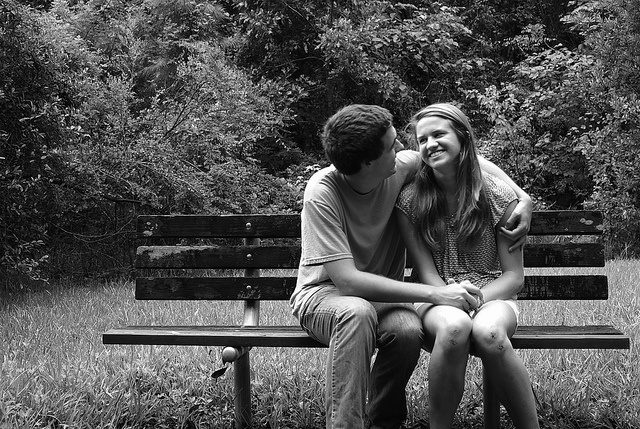Describe the objects in this image and their specific colors. I can see bench in gray, black, darkgray, and lightgray tones, people in gray, black, darkgray, and lightgray tones, and people in gray, black, darkgray, and lightgray tones in this image. 